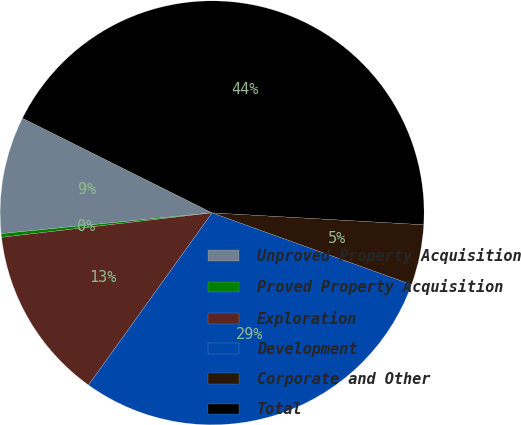<chart> <loc_0><loc_0><loc_500><loc_500><pie_chart><fcel>Unproved Property Acquisition<fcel>Proved Property Acquisition<fcel>Exploration<fcel>Development<fcel>Corporate and Other<fcel>Total<nl><fcel>8.93%<fcel>0.28%<fcel>13.25%<fcel>29.41%<fcel>4.6%<fcel>43.53%<nl></chart> 